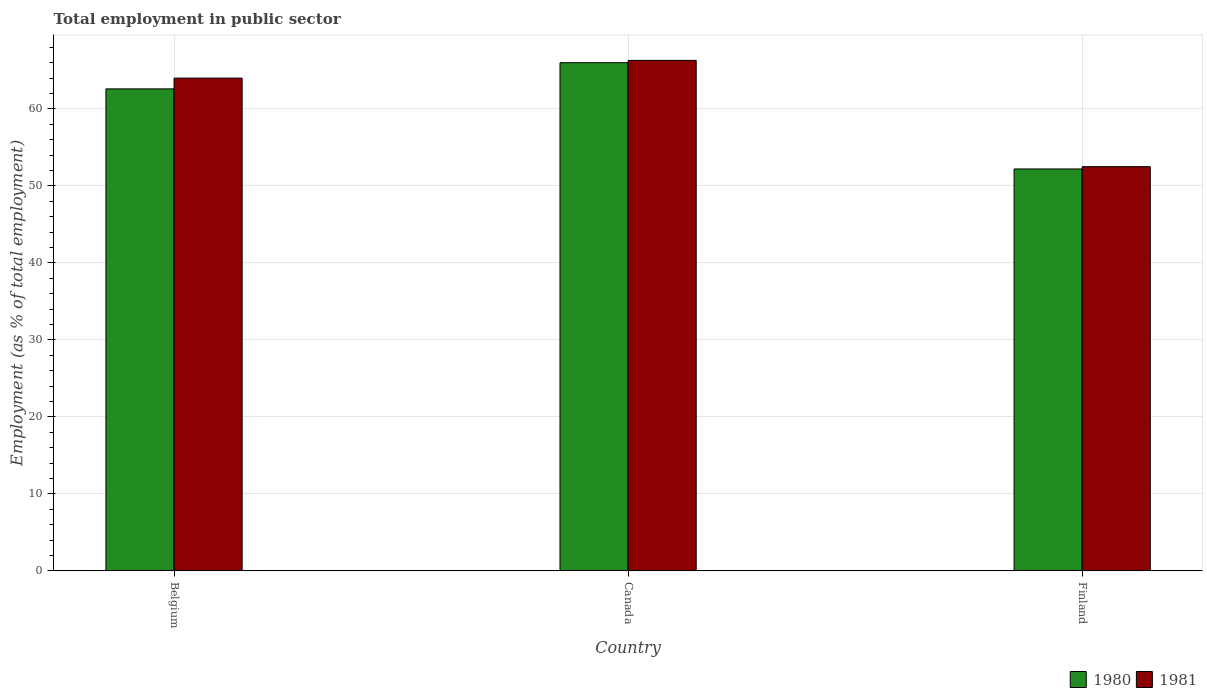How many different coloured bars are there?
Give a very brief answer. 2. Are the number of bars on each tick of the X-axis equal?
Ensure brevity in your answer.  Yes. How many bars are there on the 2nd tick from the left?
Offer a very short reply. 2. How many bars are there on the 1st tick from the right?
Ensure brevity in your answer.  2. What is the employment in public sector in 1980 in Canada?
Offer a terse response. 66. Across all countries, what is the maximum employment in public sector in 1981?
Your response must be concise. 66.3. Across all countries, what is the minimum employment in public sector in 1980?
Ensure brevity in your answer.  52.2. In which country was the employment in public sector in 1981 minimum?
Offer a very short reply. Finland. What is the total employment in public sector in 1980 in the graph?
Keep it short and to the point. 180.8. What is the difference between the employment in public sector in 1981 in Belgium and that in Canada?
Your response must be concise. -2.3. What is the difference between the employment in public sector in 1981 in Finland and the employment in public sector in 1980 in Belgium?
Your answer should be very brief. -10.1. What is the average employment in public sector in 1980 per country?
Offer a terse response. 60.27. What is the difference between the employment in public sector of/in 1981 and employment in public sector of/in 1980 in Canada?
Provide a short and direct response. 0.3. What is the ratio of the employment in public sector in 1980 in Canada to that in Finland?
Provide a succinct answer. 1.26. Is the employment in public sector in 1980 in Canada less than that in Finland?
Your response must be concise. No. Is the difference between the employment in public sector in 1981 in Belgium and Finland greater than the difference between the employment in public sector in 1980 in Belgium and Finland?
Provide a succinct answer. Yes. What is the difference between the highest and the second highest employment in public sector in 1981?
Your response must be concise. -2.3. What is the difference between the highest and the lowest employment in public sector in 1981?
Your answer should be compact. 13.8. In how many countries, is the employment in public sector in 1981 greater than the average employment in public sector in 1981 taken over all countries?
Ensure brevity in your answer.  2. Is the sum of the employment in public sector in 1981 in Canada and Finland greater than the maximum employment in public sector in 1980 across all countries?
Your answer should be very brief. Yes. What does the 1st bar from the right in Canada represents?
Your response must be concise. 1981. Are all the bars in the graph horizontal?
Provide a succinct answer. No. How many countries are there in the graph?
Provide a short and direct response. 3. What is the difference between two consecutive major ticks on the Y-axis?
Make the answer very short. 10. Does the graph contain any zero values?
Provide a short and direct response. No. Does the graph contain grids?
Offer a terse response. Yes. Where does the legend appear in the graph?
Offer a terse response. Bottom right. What is the title of the graph?
Provide a succinct answer. Total employment in public sector. Does "1965" appear as one of the legend labels in the graph?
Make the answer very short. No. What is the label or title of the X-axis?
Provide a short and direct response. Country. What is the label or title of the Y-axis?
Your answer should be compact. Employment (as % of total employment). What is the Employment (as % of total employment) of 1980 in Belgium?
Offer a very short reply. 62.6. What is the Employment (as % of total employment) in 1981 in Belgium?
Your response must be concise. 64. What is the Employment (as % of total employment) in 1981 in Canada?
Offer a very short reply. 66.3. What is the Employment (as % of total employment) in 1980 in Finland?
Make the answer very short. 52.2. What is the Employment (as % of total employment) in 1981 in Finland?
Offer a terse response. 52.5. Across all countries, what is the maximum Employment (as % of total employment) in 1981?
Make the answer very short. 66.3. Across all countries, what is the minimum Employment (as % of total employment) of 1980?
Offer a very short reply. 52.2. Across all countries, what is the minimum Employment (as % of total employment) of 1981?
Your answer should be very brief. 52.5. What is the total Employment (as % of total employment) of 1980 in the graph?
Provide a short and direct response. 180.8. What is the total Employment (as % of total employment) in 1981 in the graph?
Provide a succinct answer. 182.8. What is the difference between the Employment (as % of total employment) in 1980 in Belgium and that in Canada?
Keep it short and to the point. -3.4. What is the difference between the Employment (as % of total employment) in 1981 in Belgium and that in Canada?
Your response must be concise. -2.3. What is the difference between the Employment (as % of total employment) in 1980 in Belgium and that in Finland?
Give a very brief answer. 10.4. What is the difference between the Employment (as % of total employment) of 1980 in Belgium and the Employment (as % of total employment) of 1981 in Canada?
Keep it short and to the point. -3.7. What is the difference between the Employment (as % of total employment) in 1980 in Belgium and the Employment (as % of total employment) in 1981 in Finland?
Your answer should be very brief. 10.1. What is the difference between the Employment (as % of total employment) of 1980 in Canada and the Employment (as % of total employment) of 1981 in Finland?
Make the answer very short. 13.5. What is the average Employment (as % of total employment) in 1980 per country?
Offer a terse response. 60.27. What is the average Employment (as % of total employment) in 1981 per country?
Offer a terse response. 60.93. What is the difference between the Employment (as % of total employment) in 1980 and Employment (as % of total employment) in 1981 in Belgium?
Your response must be concise. -1.4. What is the difference between the Employment (as % of total employment) in 1980 and Employment (as % of total employment) in 1981 in Finland?
Make the answer very short. -0.3. What is the ratio of the Employment (as % of total employment) of 1980 in Belgium to that in Canada?
Your answer should be very brief. 0.95. What is the ratio of the Employment (as % of total employment) of 1981 in Belgium to that in Canada?
Your answer should be compact. 0.97. What is the ratio of the Employment (as % of total employment) in 1980 in Belgium to that in Finland?
Give a very brief answer. 1.2. What is the ratio of the Employment (as % of total employment) in 1981 in Belgium to that in Finland?
Offer a very short reply. 1.22. What is the ratio of the Employment (as % of total employment) of 1980 in Canada to that in Finland?
Keep it short and to the point. 1.26. What is the ratio of the Employment (as % of total employment) in 1981 in Canada to that in Finland?
Offer a very short reply. 1.26. What is the difference between the highest and the second highest Employment (as % of total employment) in 1980?
Ensure brevity in your answer.  3.4. What is the difference between the highest and the second highest Employment (as % of total employment) in 1981?
Your answer should be very brief. 2.3. What is the difference between the highest and the lowest Employment (as % of total employment) in 1981?
Provide a succinct answer. 13.8. 